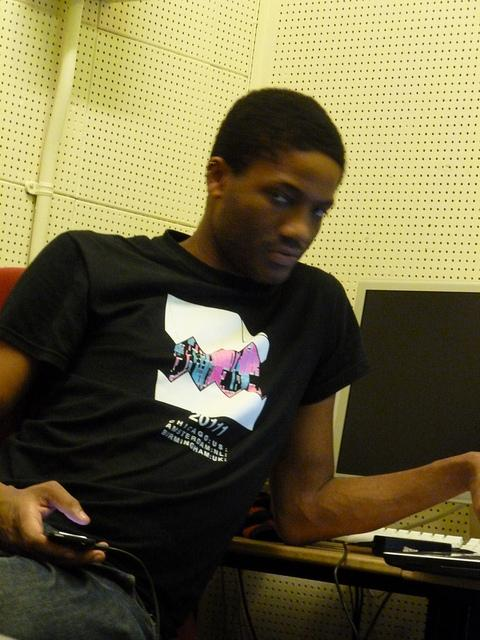What is the purpose of the holes behind him?

Choices:
A) ventilation
B) seeing outside
C) decoration
D) hanging things hanging things 